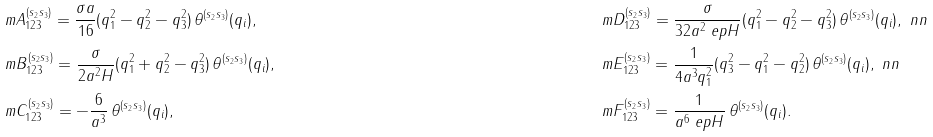<formula> <loc_0><loc_0><loc_500><loc_500>& \ m A ^ { ( s _ { 2 } s _ { 3 } ) } _ { 1 2 3 } = \frac { \sigma a } { 1 6 } ( q _ { 1 } ^ { 2 } - q _ { 2 } ^ { 2 } - q _ { 3 } ^ { 2 } ) \, \theta ^ { ( s _ { 2 } s _ { 3 } ) } ( q _ { i } ) , \quad & & \ m D ^ { ( s _ { 2 } s _ { 3 } ) } _ { 1 2 3 } = \frac { \sigma } { 3 2 a ^ { 2 } \ e p H } ( q _ { 1 } ^ { 2 } - q _ { 2 } ^ { 2 } - q _ { 3 } ^ { 2 } ) \, \theta ^ { ( s _ { 2 } s _ { 3 } ) } ( q _ { i } ) , \ n n \\ & \ m B ^ { ( s _ { 2 } s _ { 3 } ) } _ { 1 2 3 } = \frac { \sigma } { 2 a ^ { 2 } H } ( q _ { 1 } ^ { 2 } + q _ { 2 } ^ { 2 } - q _ { 3 } ^ { 2 } ) \, \theta ^ { ( s _ { 2 } s _ { 3 } ) } ( q _ { i } ) , \quad & & \ m E ^ { ( s _ { 2 } s _ { 3 } ) } _ { 1 2 3 } = \frac { 1 } { 4 a ^ { 3 } q _ { 1 } ^ { 2 } } ( q _ { 3 } ^ { 2 } - q _ { 1 } ^ { 2 } - q _ { 2 } ^ { 2 } ) \, \theta ^ { ( s _ { 2 } s _ { 3 } ) } ( q _ { i } ) , \ n n \\ & \ m C ^ { ( s _ { 2 } s _ { 3 } ) } _ { 1 2 3 } = - \frac { 6 } { a ^ { 3 } } \, \theta ^ { ( s _ { 2 } s _ { 3 } ) } ( q _ { i } ) , \quad & & \ m F ^ { ( s _ { 2 } s _ { 3 } ) } _ { 1 2 3 } = \frac { 1 } { a ^ { 6 } \ e p H } \, \theta ^ { ( s _ { 2 } s _ { 3 } ) } ( q _ { i } ) .</formula> 